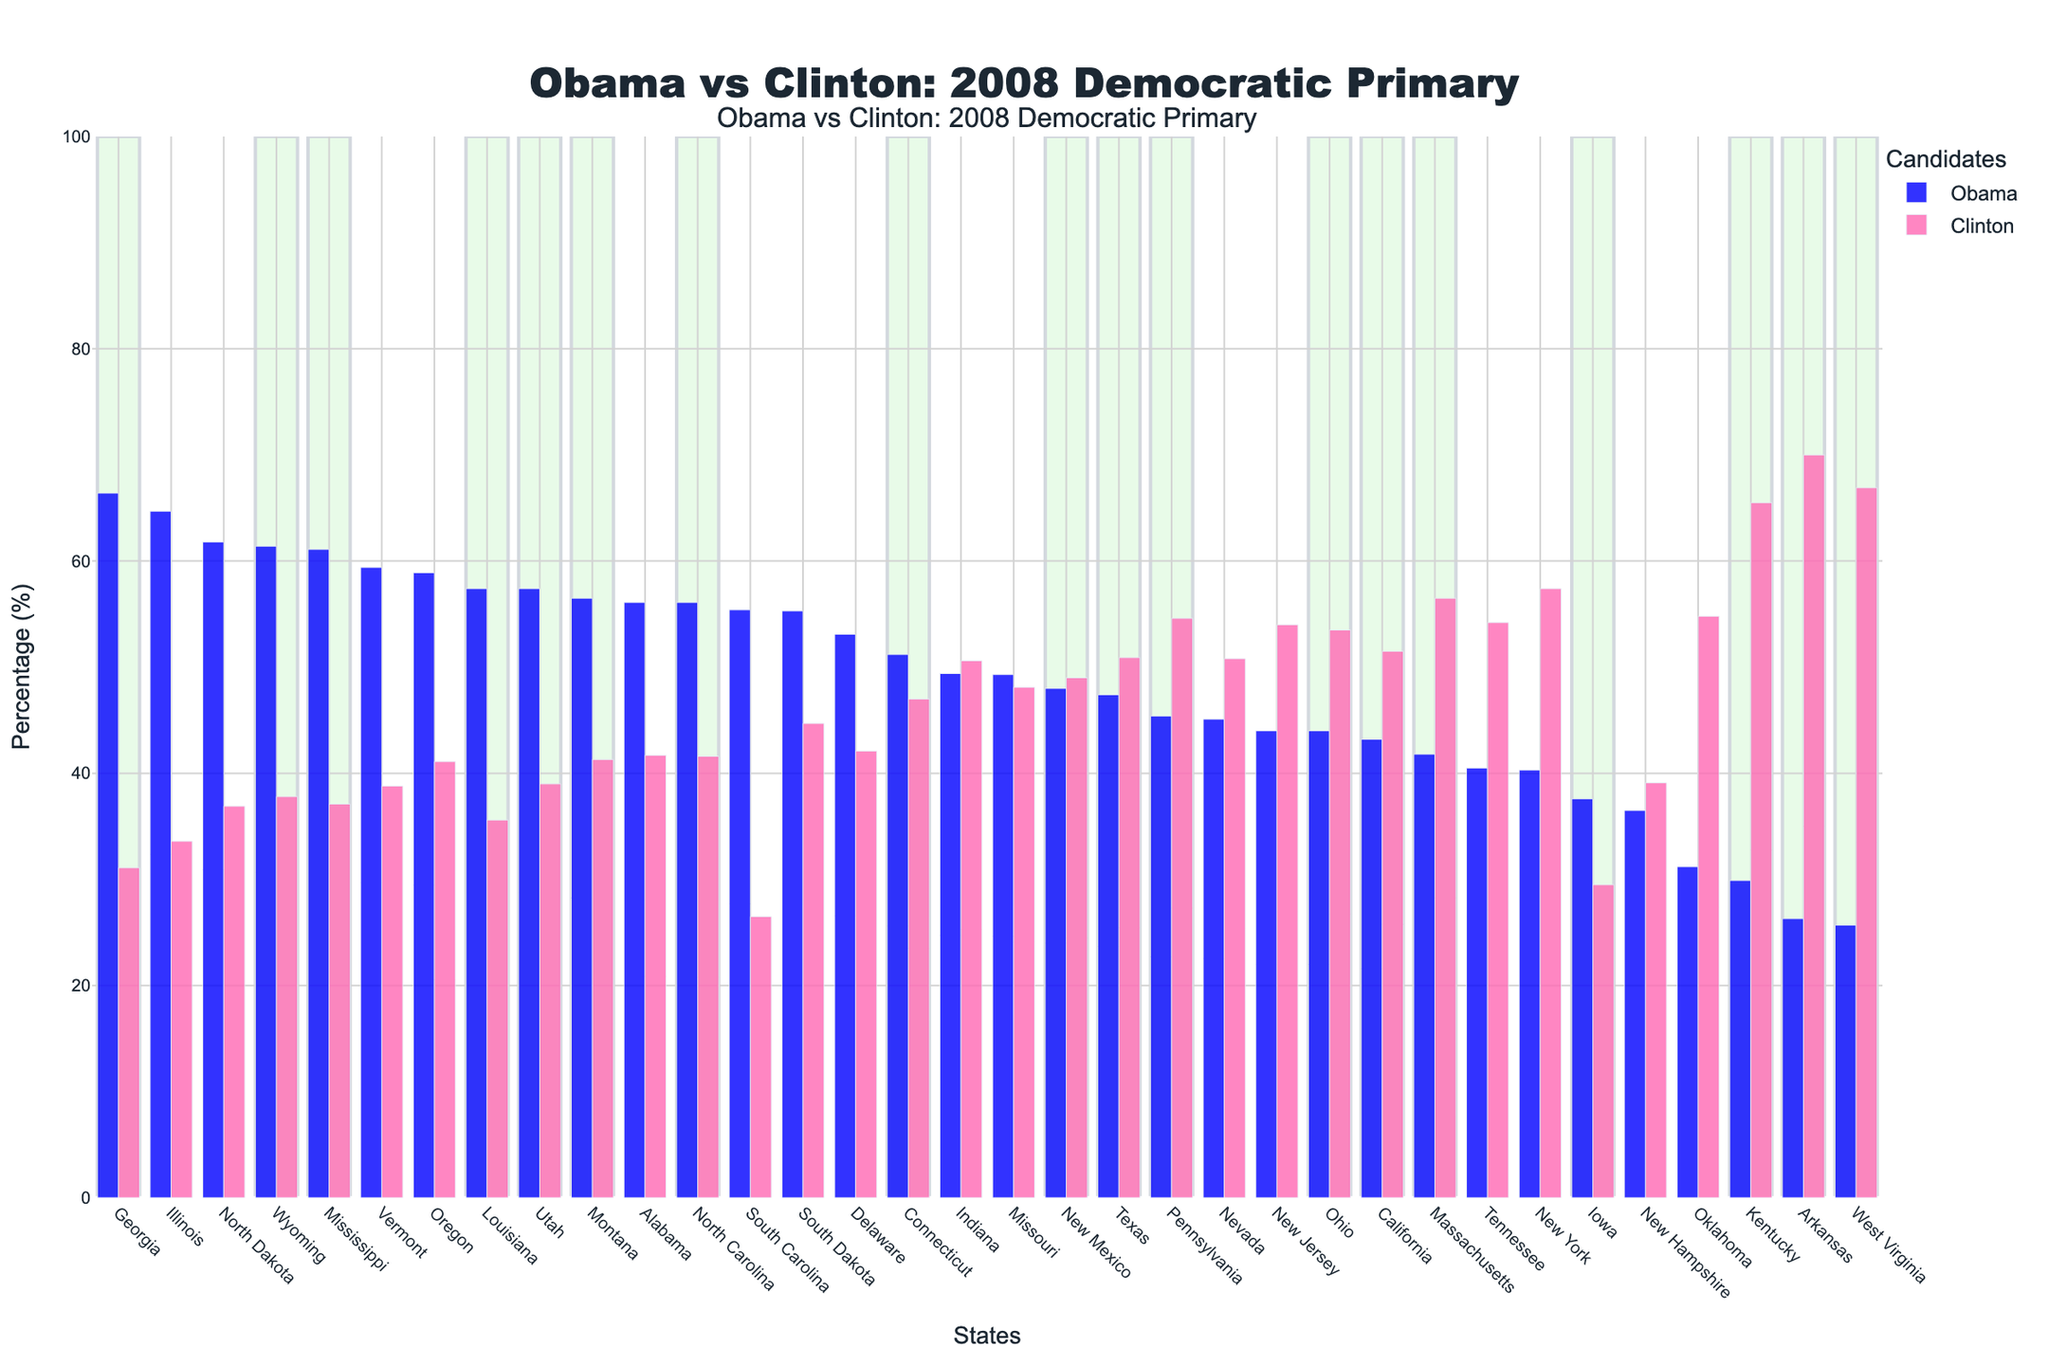Which state had the highest percentage support for Obama? Look at the bars representing Obama in blue and find the tallest one. The state corresponding to this bar is Georgia.
Answer: Georgia How many states did Obama win with more than 60% of the vote? Identify the bars with a blue color that exceed 60% on the y-axis and count how many states these bars represent. There are 8 such states: Georgia, Illinois, North Dakota, Idaho, Utah, Vermont, Wyoming, and Mississippi.
Answer: 8 Which state showed the smallest percentage difference between Obama and Clinton? Calculate the percentage difference between Obama and Clinton for each state and find the smallest difference. For Missouri, the difference is 49.3 - 48.1 = 1.2.
Answer: Missouri In which states did Obama perform better than Clinton but with less than 50% of the vote? Identify the states where the blue bar is taller than the pink bar but doesn’t reach the 50% mark. These states are Missouri, Indiana, and New Mexico.
Answer: Missouri, Indiana, New Mexico Which candidate had more states where their percentage of votes exceeded 50%? Count the number of states where the blue or pink bars are taller than the 50% mark. Obama has 15 states (marked in light green), while Clinton has 13.
Answer: Obama How does the number of states where Obama had more than 55% compare to those where Clinton had more than 55%? Identify and count the states where Obama’s blue bar exceeds 55% and those where Clinton’s pink bar does. Obama: 9 states; Clinton: 5 states.
Answer: Obama > Clinton What is the average percentage of votes for Obama across all states? Sum up the percentages of votes for Obama across all the states and divide by the number of states (36). The sum is 47.4 + 49.3 +  ... + 55.3, which totals 1778. So, 1778 / 36 = 49.39%.
Answer: 49.39% In which states did Hillary Clinton receive more than twice the percentage of votes as Obama? For each state, compare Clinton's percentage to twice that of Obama's percentage. If Clinton received more, identify those states. This applies to Arkansas and West Virginia.
Answer: Arkansas, West Virginia 